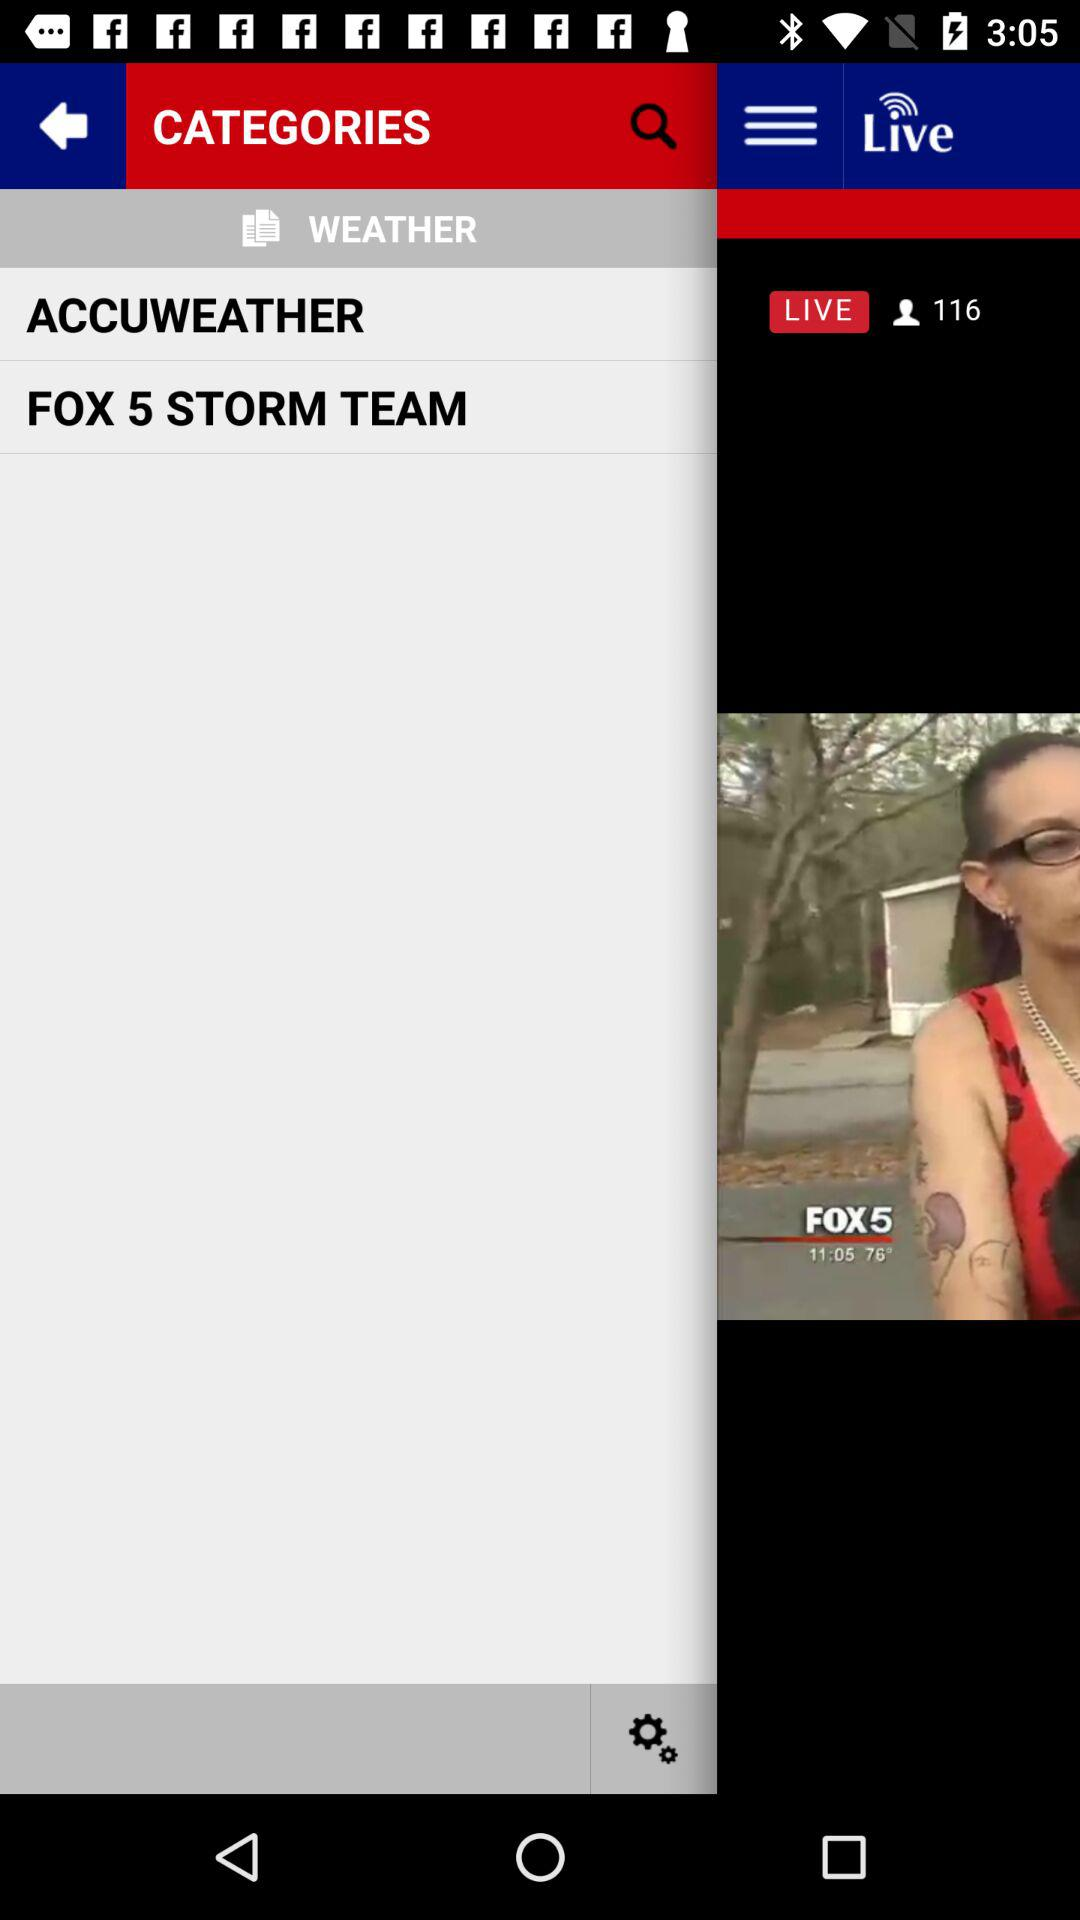At what place was the woman arrested? The woman was arrested at gate E-34 of Atlanta Hartsfield-Jackson International Airport. 